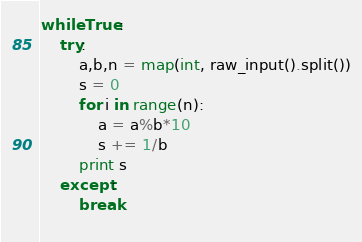Convert code to text. <code><loc_0><loc_0><loc_500><loc_500><_Python_>while True:
    try:
        a,b,n = map(int, raw_input().split())
        s = 0
        for i in range(n):
            a = a%b*10
            s += 1/b
        print s
    except:
        break
        </code> 